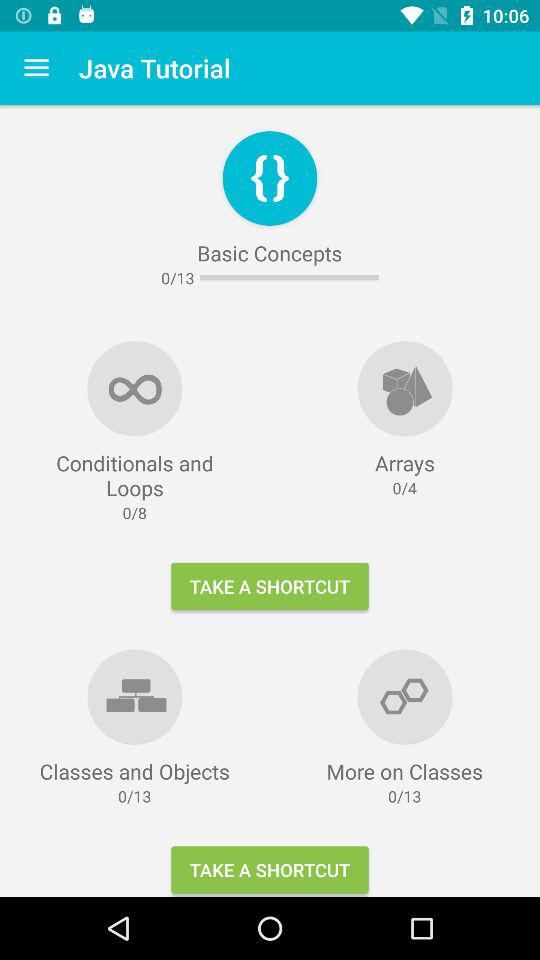How many modules in total are there in "Basic Concepts" in "Java Tutorial"? There are 13 modules in total in "Basic Concepts" in "Java Tutorial". 